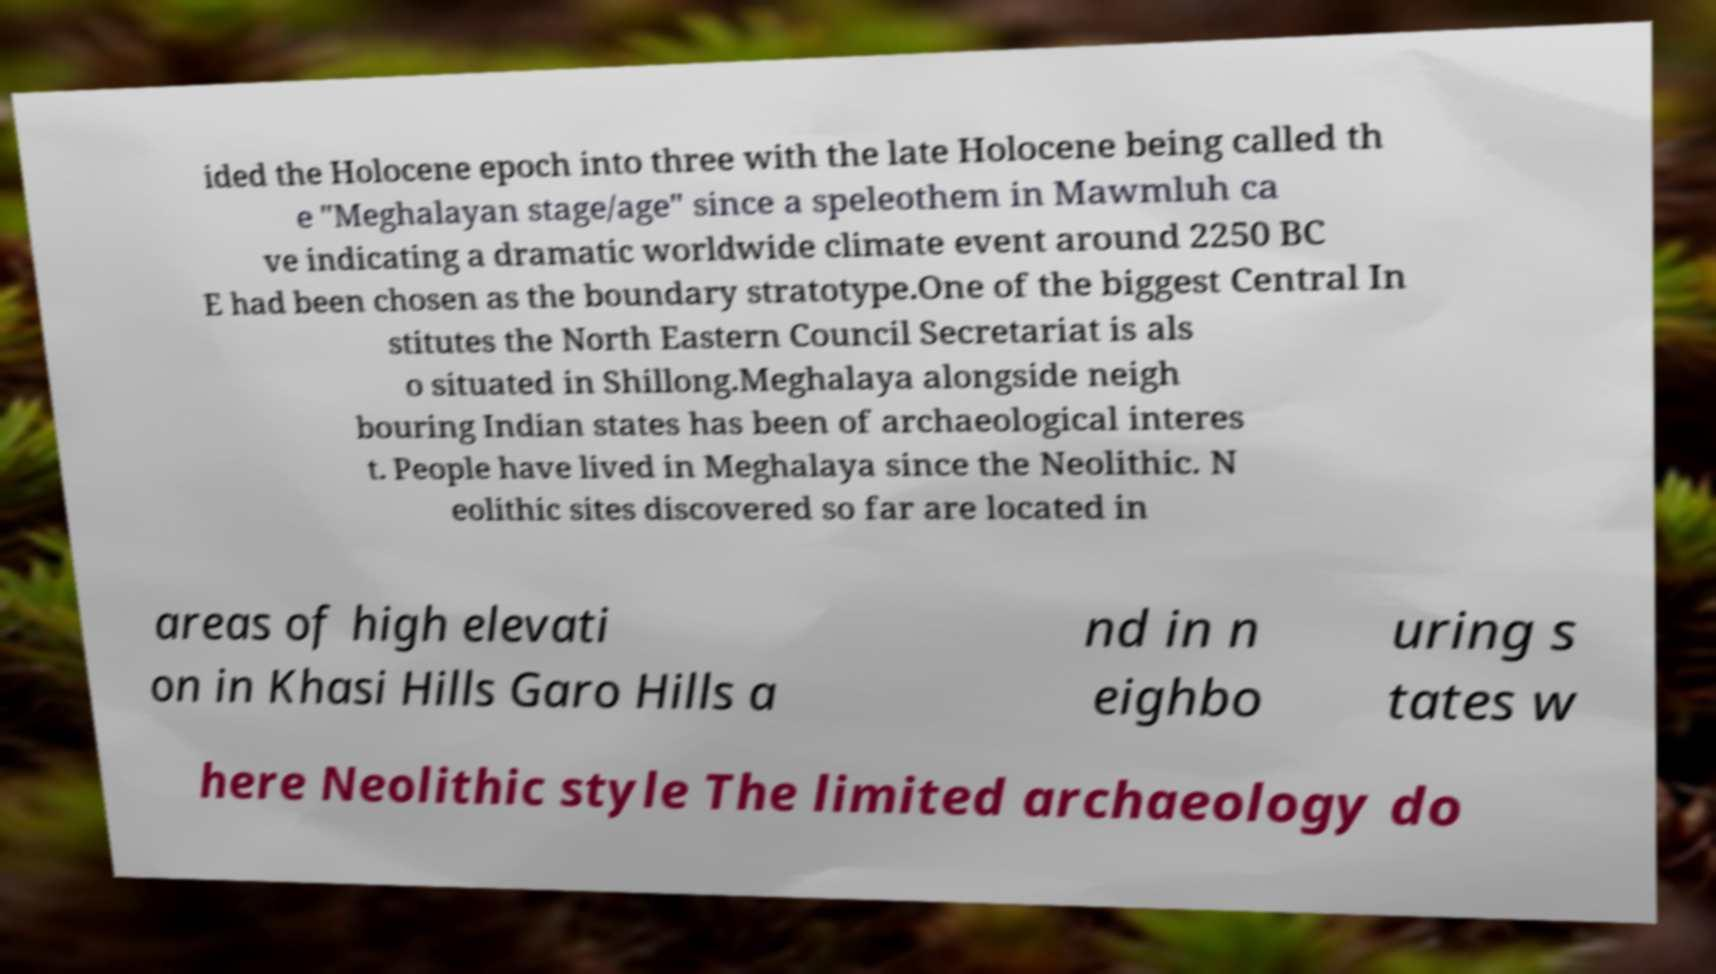Please identify and transcribe the text found in this image. ided the Holocene epoch into three with the late Holocene being called th e "Meghalayan stage/age" since a speleothem in Mawmluh ca ve indicating a dramatic worldwide climate event around 2250 BC E had been chosen as the boundary stratotype.One of the biggest Central In stitutes the North Eastern Council Secretariat is als o situated in Shillong.Meghalaya alongside neigh bouring Indian states has been of archaeological interes t. People have lived in Meghalaya since the Neolithic. N eolithic sites discovered so far are located in areas of high elevati on in Khasi Hills Garo Hills a nd in n eighbo uring s tates w here Neolithic style The limited archaeology do 